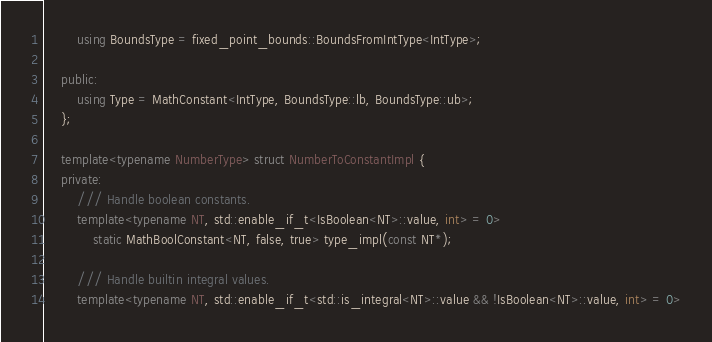Convert code to text. <code><loc_0><loc_0><loc_500><loc_500><_C++_>        using BoundsType = fixed_point_bounds::BoundsFromIntType<IntType>;

    public:
        using Type = MathConstant<IntType, BoundsType::lb, BoundsType::ub>;
    };

    template<typename NumberType> struct NumberToConstantImpl {
    private:
        /// Handle boolean constants.
        template<typename NT, std::enable_if_t<IsBoolean<NT>::value, int> = 0>
            static MathBoolConstant<NT, false, true> type_impl(const NT*);

        /// Handle builtin integral values.
        template<typename NT, std::enable_if_t<std::is_integral<NT>::value && !IsBoolean<NT>::value, int> = 0></code> 